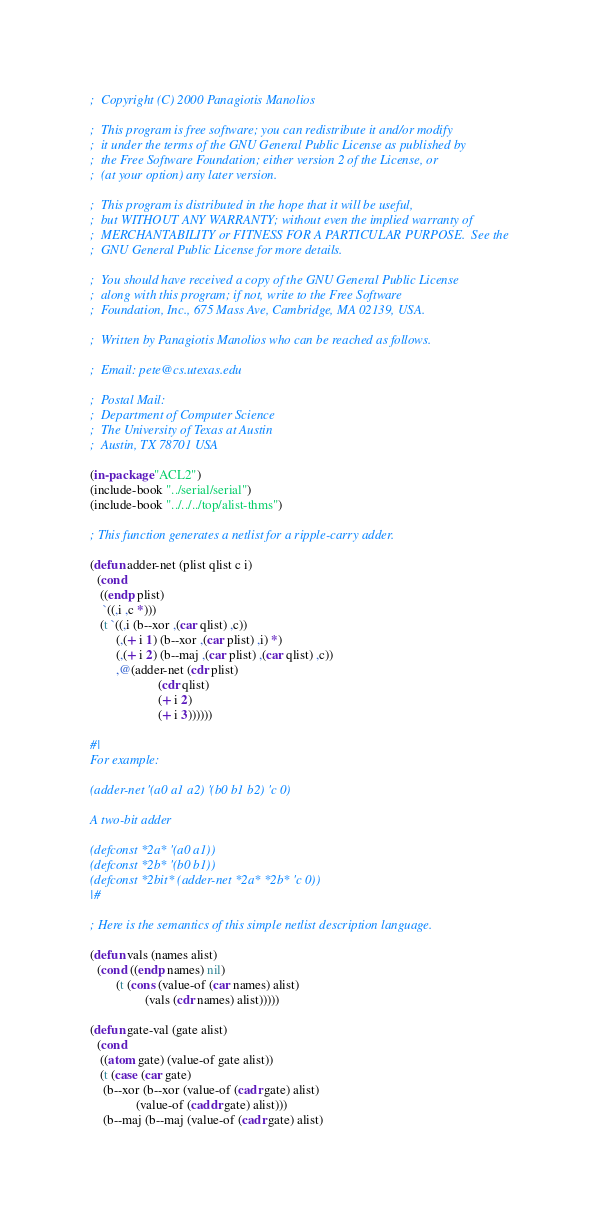<code> <loc_0><loc_0><loc_500><loc_500><_Lisp_>;  Copyright (C) 2000 Panagiotis Manolios

;  This program is free software; you can redistribute it and/or modify
;  it under the terms of the GNU General Public License as published by
;  the Free Software Foundation; either version 2 of the License, or
;  (at your option) any later version.

;  This program is distributed in the hope that it will be useful,
;  but WITHOUT ANY WARRANTY; without even the implied warranty of
;  MERCHANTABILITY or FITNESS FOR A PARTICULAR PURPOSE.  See the
;  GNU General Public License for more details.

;  You should have received a copy of the GNU General Public License
;  along with this program; if not, write to the Free Software
;  Foundation, Inc., 675 Mass Ave, Cambridge, MA 02139, USA.

;  Written by Panagiotis Manolios who can be reached as follows.

;  Email: pete@cs.utexas.edu

;  Postal Mail:
;  Department of Computer Science
;  The University of Texas at Austin
;  Austin, TX 78701 USA

(in-package "ACL2")
(include-book "../serial/serial")
(include-book "../../../top/alist-thms")

; This function generates a netlist for a ripple-carry adder.

(defun adder-net (plist qlist c i)
  (cond
   ((endp plist)
    `((,i ,c *)))
   (t `((,i (b--xor ,(car qlist) ,c))
        (,(+ i 1) (b--xor ,(car plist) ,i) *)
        (,(+ i 2) (b--maj ,(car plist) ,(car qlist) ,c))
        ,@(adder-net (cdr plist)
                     (cdr qlist)
                     (+ i 2)
                     (+ i 3))))))

#|
For example:

(adder-net '(a0 a1 a2) '(b0 b1 b2) 'c 0)

A two-bit adder

(defconst *2a* '(a0 a1))
(defconst *2b* '(b0 b1))
(defconst *2bit* (adder-net *2a* *2b* 'c 0))
|#

; Here is the semantics of this simple netlist description language.

(defun vals (names alist)
  (cond ((endp names) nil)
        (t (cons (value-of (car names) alist)
                 (vals (cdr names) alist)))))

(defun gate-val (gate alist)
  (cond
   ((atom gate) (value-of gate alist))
   (t (case (car gate)
	(b--xor (b--xor (value-of (cadr gate) alist)
		      (value-of (caddr gate) alist)))
	(b--maj (b--maj (value-of (cadr gate) alist)</code> 